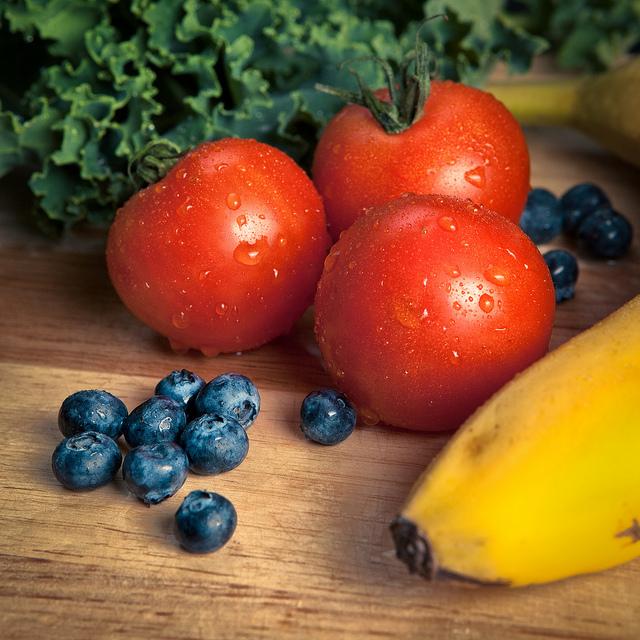What location grows these food items?
Be succinct. Farm. What are these?
Short answer required. Fruit. Why is the fruit wet?
Give a very brief answer. Washed. What kind of fruit is on the left?
Be succinct. Blueberry. What fruit is black in color?
Answer briefly. Blueberries. Will these fruits and veggies be used for a smoothie?
Write a very short answer. Yes. Are there grapes amongst the fruit?
Be succinct. No. What is the red vegetable?
Be succinct. Tomato. How many vegetables are there?
Write a very short answer. 1. What kind of vegetables are shown?
Be succinct. Tomatoes. 